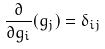Convert formula to latex. <formula><loc_0><loc_0><loc_500><loc_500>\frac { \partial } { \partial g _ { i } } ( g _ { j } ) = \delta _ { i j }</formula> 